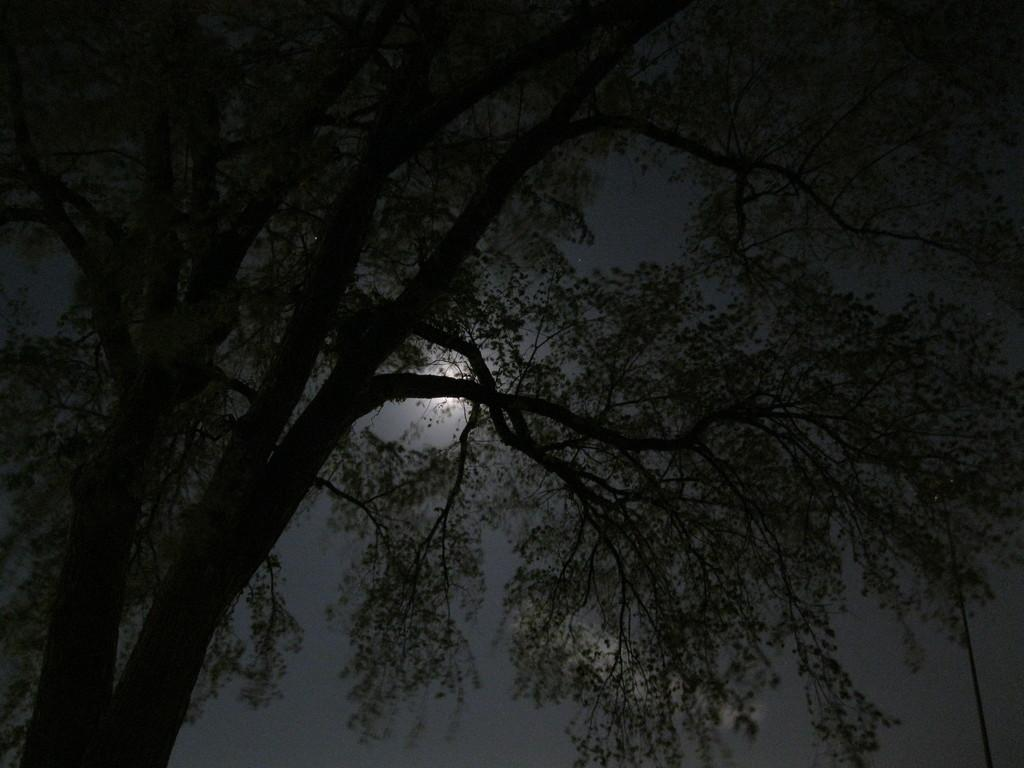What is the main object in the image? There is a tree in the image. Can you describe the colors of the tree? The tree has black and green colors. What can be seen in the background of the image? The sky is visible in the background of the image. How would you describe the sky in the image? The sky is dark in the image. What celestial body is visible in the sky? The moon is visible in the sky. What type of system is being used to communicate with the ghost in the image? There is no ghost or communication system present in the image; it features a tree, a dark sky, and the moon. 